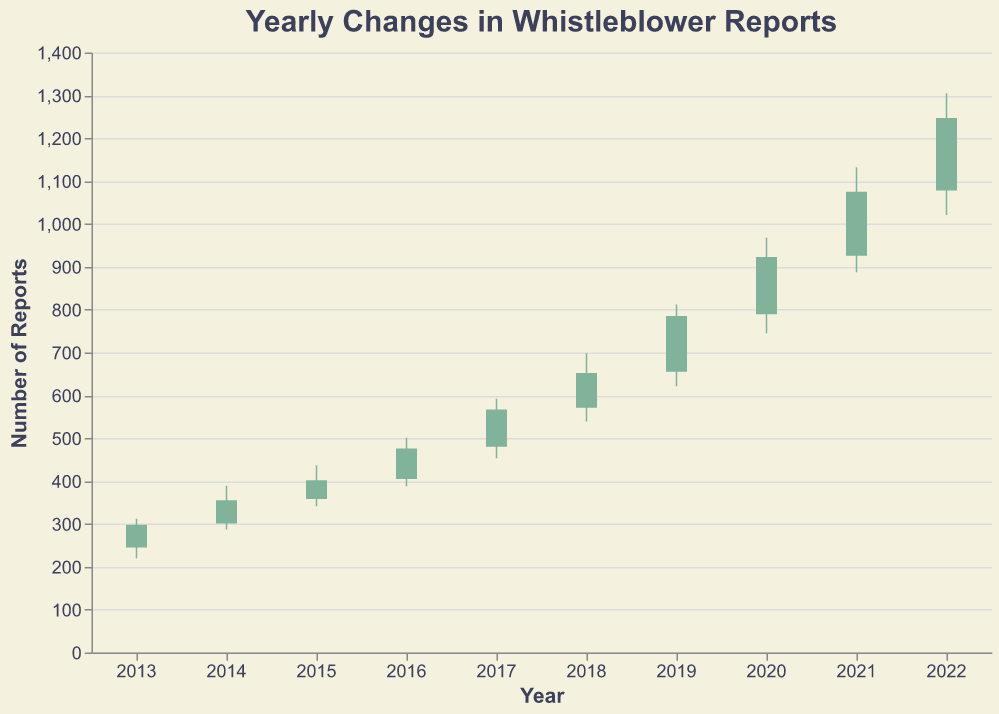What is the title of the chart? The title is located at the top of the chart. It serves as a summary of what the chart represents.
Answer: Yearly Changes in Whistleblower Reports How many years of data are presented in the chart? The x-axis of the chart lists the years from 2013 to 2022. Counting these years gives the total number.
Answer: 10 What were the opening and closing numbers of whistleblower reports for 2017? Look at the bar corresponding to 2017. The bottom of the bar is marked by the opening number (480), and the top is marked by the closing number (567).
Answer: Open: 480, Close: 567 Which year had the highest closing number of whistleblower reports? Compare the closing numbers on the top of each bar across all years.
Answer: 2022 In which year did the number of whistleblower reports increase the most based on the closing numbers? Subtract the closing number of the previous year from the current year's closing number for each year to find the largest difference.
Answer: 2020 (Close increased by 138) What is the minimum number of whistleblower reports recorded in any given year? The 'Low' value in the data represents the minimum number recorded in any year. Look at the smallest 'Low' value in the chart.
Answer: 220 (in 2013) What is the average of the high numbers from 2015 to 2020? Sum the high values for these years and divide by the count (6 years). (437 + 501 + 592 + 698 + 812 + 968) ÷ 6
Answer: 668 Compare the range of reports in 2018 vs 2021. Which year had a larger range? The range in each year is calculated by subtracting the low value from the high value. Compare the ranges. (2018: 698 − 539, 2021: 1132 − 887)
Answer: 2021 (245 vs 159) Which year shows a drop in the number of whistleblower reports based on opening and closing values? Check each year's data to see if the closing number is less than the opening number.
Answer: No year shows a drop What was the difference between the highest recorded number and the lowest recorded number of reports in 2019? Subtract the lowest value from the highest value for the year 2019.
Answer: 191 (812 − 621) 